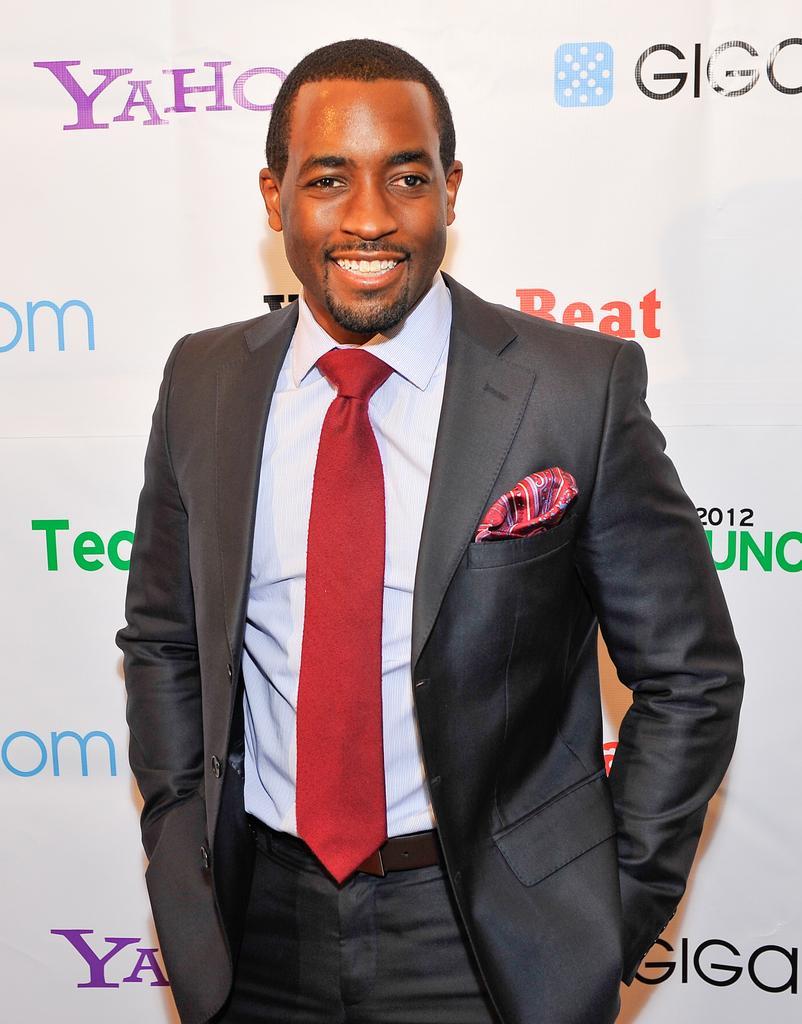In one or two sentences, can you explain what this image depicts? In this image I can see a person standing and the person is wearing gray color blazer, white shirt and red tie, background I can see a banner and I can see something written on the banner. 